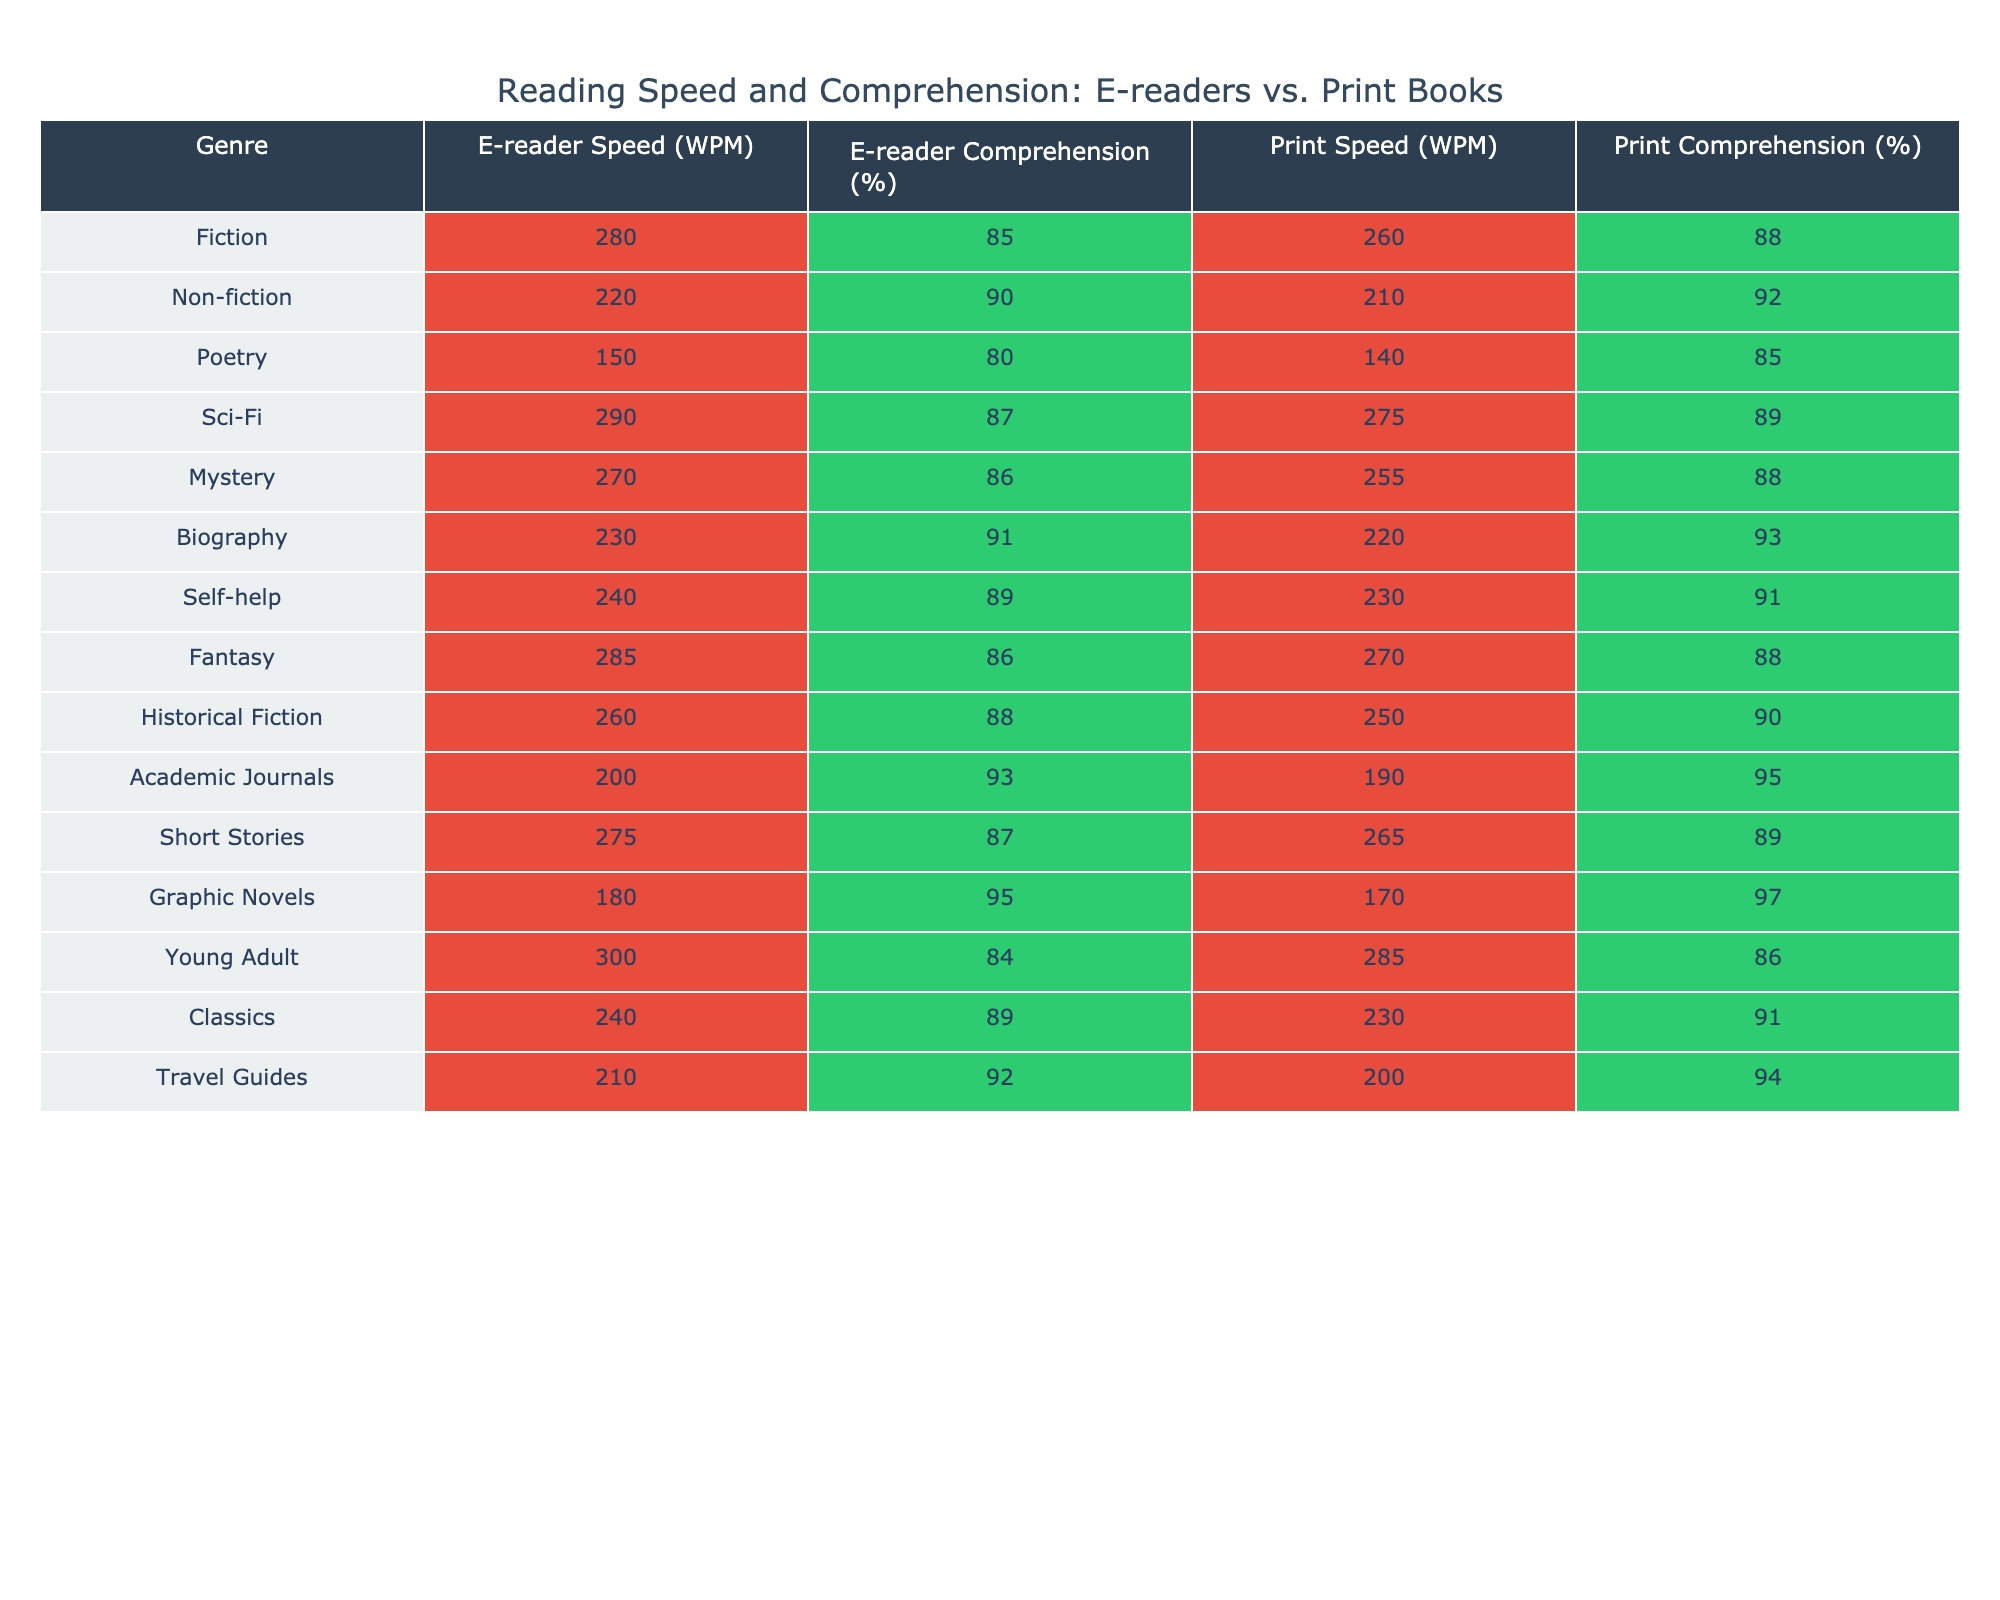What's the reading speed for Fiction on E-readers? The table shows the E-reader Speed for Fiction is listed as 280 WPM.
Answer: 280 WPM Which genre has the highest comprehension percentage when read in print? The highest comprehension percentage for print is found in Graphic Novels at 97%.
Answer: 97% What is the difference in reading speed between Sci-Fi on E-readers and Print? The reading speed for Sci-Fi on E-readers is 290 WPM, while for Print it is 275 WPM. The difference is 290 - 275 = 15 WPM.
Answer: 15 WPM Is the comprehension percentage for Non-fiction higher in print than on an e-reader? The comprehension percentage for Non-fiction in print is 92%, while on an e-reader it is 90%. Since 92% is greater than 90%, the statement is true.
Answer: Yes What is the average reading speed for all genres on E-readers? The reading speeds are 280, 220, 150, 290, 270, 230, 240, 285, 260, 200, 275, 180, 300, 240, and 210 WPM. Summing these gives 3,355. There are 15 genres, so the average is 3,355 / 15 = 223.67 WPM.
Answer: 223.67 WPM For which genre is the difference in comprehension percentage greatest between e-readers and print? Testing each genre: for Biography, the difference is 93% - 91% = 2%, for Poetry, it's 85% - 80% = 5%, leading to the largest difference for Graphic Novels, 97% - 95% = 2%. However, Poetry has 5%, which is the largest overall.
Answer: Poetry Which genre has lower comprehension remembering in print compared to an e-reader? Comparing the comprehension percentages for all genres, Poetry, which scores 80% in e-reader version and 85% in print, is the only genre with a larger score in print.
Answer: No What is the difference in average comprehension percentage between E-readers and Print for all genres? The average comprehension percentages are calculated as follows: E-readers (85, 90, 80, 87, 86, 91, 89, 86, 88, 93, 87, 95, 84, 89, 92) average to 87.27%, while Print (88, 92, 85, 89, 88, 93, 91, 88, 90, 95, 89, 97, 86, 91, 94) averages to 90.13%. The difference is 90.13 - 87.27 = 2.86%.
Answer: 2.86% Are the reading speeds for Academic Journals higher in e-readers or print? The reading speed for Academic Journals is 200 WPM on e-readers and 190 WPM in print. Since 200 > 190, the reading speed is higher for e-readers.
Answer: E-readers What genre has the lowest reading speed on E-readers? Reviewing the E-reader speeds, Poetry has the lowest at 150 WPM.
Answer: Poetry 